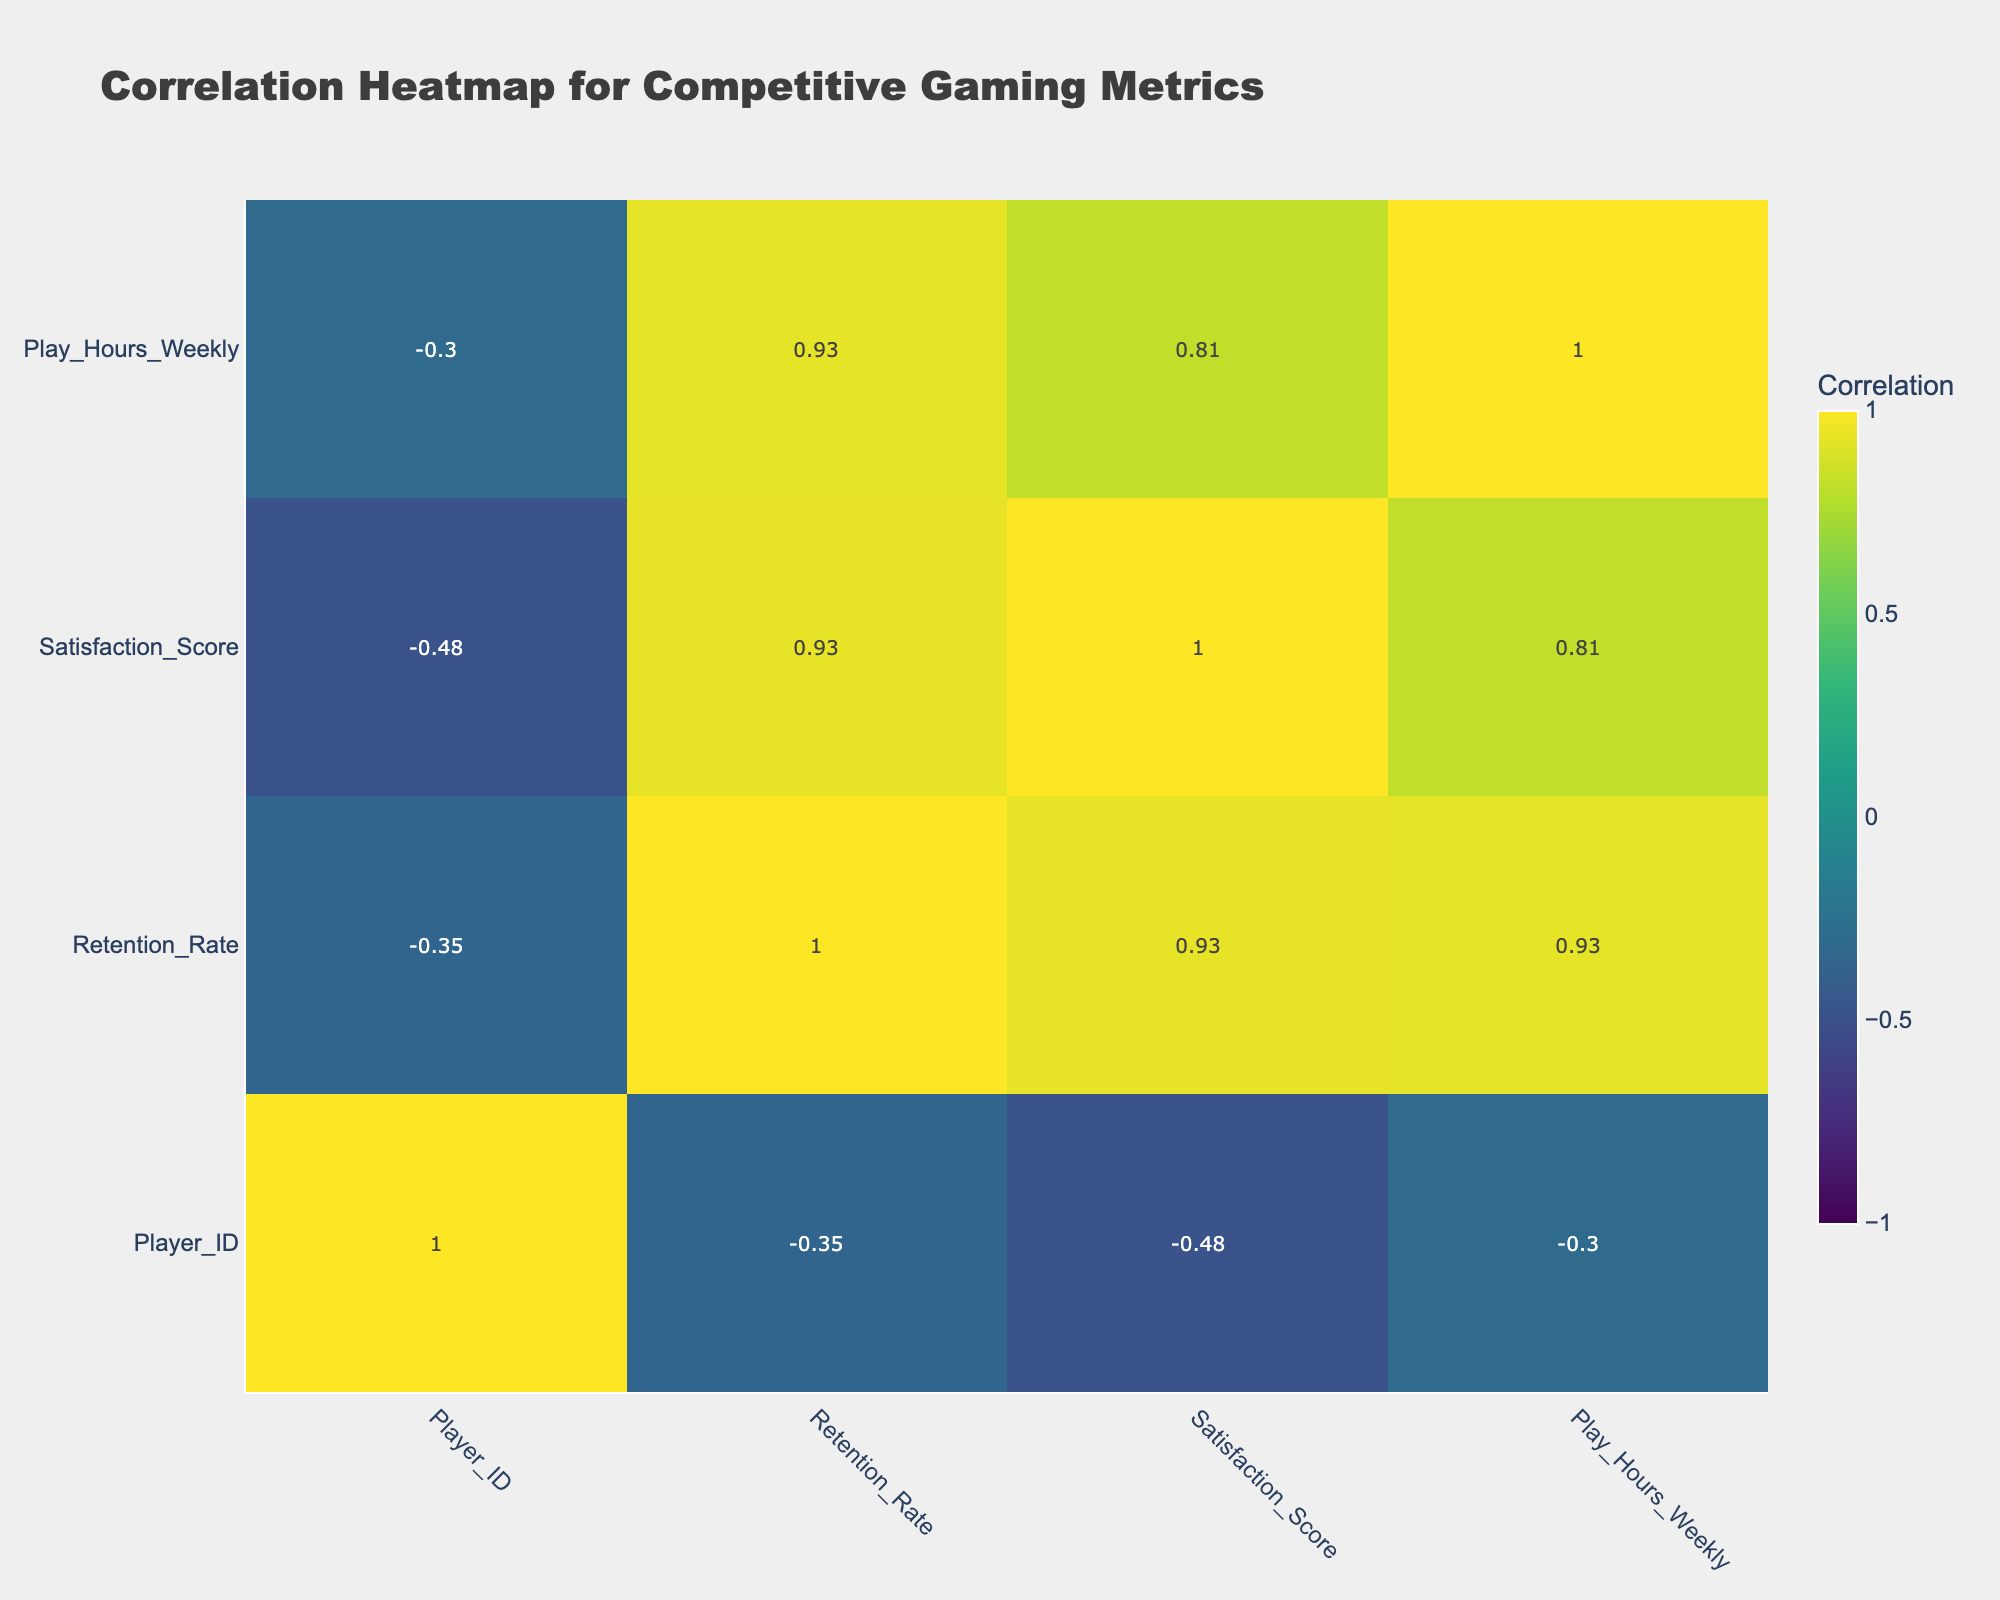What is the maximum Retention Rate in the table? The Retention Rate values in the table are 85, 60, 90, 82, 70, 75, 88, 65, 80, and 55. The maximum value among these is 90.
Answer: 90 What is the average Satisfaction Score of players who made in-game purchases? Players who made in-game purchases have Satisfaction Scores of 4.7, 4.5, 4.0, 4.2, 4.6, and 4.1. For average, sum these scores: (4.7 + 4.5 + 4.0 + 4.2 + 4.6 + 4.1) = 26.1; then divide by the number of players (6): 26.1 / 6 = 4.35.
Answer: 4.35 Is there a player with a Satisfaction Score of 3.0 or lower? Looking at the Satisfaction Scores provided, the lowest is 3.0 from Player 10. Therefore, there is a player with that score.
Answer: Yes What is the correlation between In-Game Purchases and Retention Rate? To find this, we need to derive values from the correlation matrix. Players with in-game purchases have higher retention rates on average than those without. The correlation coefficient for In-Game Purchases and Retention Rate is likely positive, indicating a positive relationship.
Answer: Positive correlation What is the difference in average Play Hours Weekly between players with and without in-game purchases? Players with in-game purchases (20, 30, 25, 22, 28, 21) have total play hours of 20 + 30 + 25 + 22 + 28 + 21 = 146 hours; dividing by 6 gives an average of 24.33 hours. Players without purchases (15, 18, 17, 10) have total play hours of 15 + 18 + 17 + 10 = 60 hours; dividing by 4 gives 15 hours. The difference is 24.33 - 15 = 9.33 hours.
Answer: 9.33 hours What is the average Retention Rate for players categorized as Platinum? Players ranked Platinum have Retention Rates of 90 (Player 3) and 88 (Player 7). To calculate the average, add these two values: 90 + 88 = 178; then divide by the number of Platinum players (2): 178 / 2 = 89.
Answer: 89 Is there a direct relationship between Competitive Rank and Satisfaction Score? A review of the table indicates that higher Competitive Ranks (Gold and Platinum) tend to have higher Satisfaction Scores. This suggests a possible direct relationship between rank and satisfaction, but correlation doesn't imply causation here without analysis to confirm.
Answer: Yes, tends to be direct What is the player with the highest Competitive Rank's Satisfaction Score? Player 3 is ranked Platinum, which is the highest Competitive Rank, with a Satisfaction Score of 4.5.
Answer: 4.5 What percentage of players have made in-game purchases? There are 10 players total, and 6 of them made in-game purchases. The percentage is (6 / 10) * 100 = 60%.
Answer: 60% 